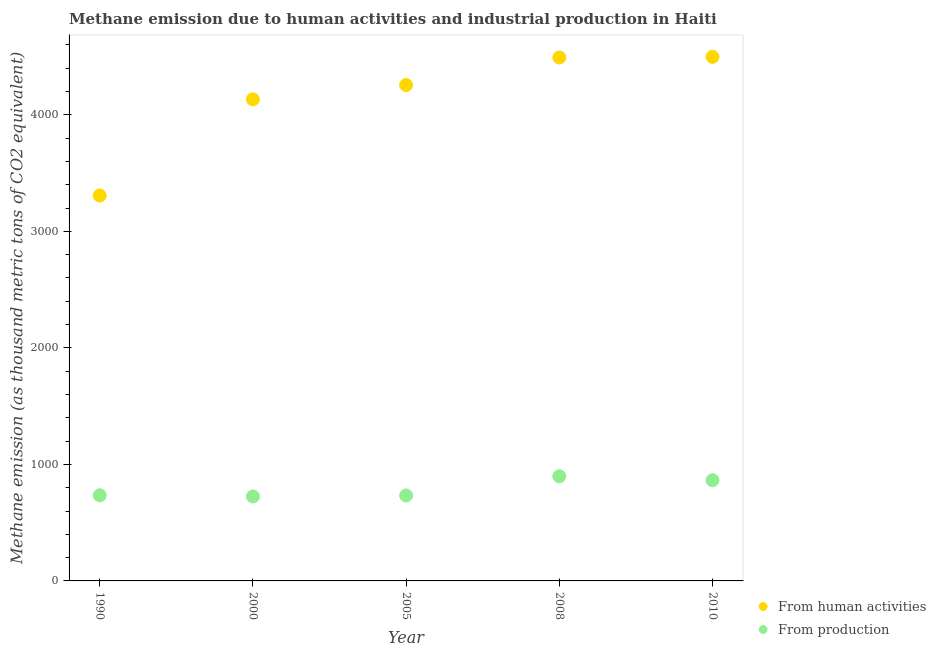How many different coloured dotlines are there?
Your response must be concise. 2. What is the amount of emissions from human activities in 2005?
Ensure brevity in your answer.  4255.4. Across all years, what is the maximum amount of emissions generated from industries?
Make the answer very short. 897.9. Across all years, what is the minimum amount of emissions from human activities?
Make the answer very short. 3307.8. In which year was the amount of emissions generated from industries minimum?
Ensure brevity in your answer.  2000. What is the total amount of emissions generated from industries in the graph?
Offer a terse response. 3955.3. What is the difference between the amount of emissions from human activities in 1990 and that in 2005?
Give a very brief answer. -947.6. What is the difference between the amount of emissions generated from industries in 2000 and the amount of emissions from human activities in 2008?
Make the answer very short. -3767.3. What is the average amount of emissions from human activities per year?
Give a very brief answer. 4137.04. In the year 2000, what is the difference between the amount of emissions generated from industries and amount of emissions from human activities?
Your answer should be very brief. -3407.8. In how many years, is the amount of emissions generated from industries greater than 3000 thousand metric tons?
Ensure brevity in your answer.  0. What is the ratio of the amount of emissions from human activities in 2000 to that in 2010?
Your response must be concise. 0.92. What is the difference between the highest and the second highest amount of emissions from human activities?
Your answer should be compact. 5.2. What is the difference between the highest and the lowest amount of emissions generated from industries?
Ensure brevity in your answer.  173.1. In how many years, is the amount of emissions from human activities greater than the average amount of emissions from human activities taken over all years?
Your response must be concise. 3. Is the sum of the amount of emissions from human activities in 2000 and 2005 greater than the maximum amount of emissions generated from industries across all years?
Offer a very short reply. Yes. Does the amount of emissions from human activities monotonically increase over the years?
Your answer should be compact. Yes. Is the amount of emissions generated from industries strictly greater than the amount of emissions from human activities over the years?
Keep it short and to the point. No. Is the amount of emissions from human activities strictly less than the amount of emissions generated from industries over the years?
Give a very brief answer. No. Are the values on the major ticks of Y-axis written in scientific E-notation?
Your response must be concise. No. Does the graph contain grids?
Offer a terse response. No. How many legend labels are there?
Make the answer very short. 2. What is the title of the graph?
Ensure brevity in your answer.  Methane emission due to human activities and industrial production in Haiti. What is the label or title of the Y-axis?
Keep it short and to the point. Methane emission (as thousand metric tons of CO2 equivalent). What is the Methane emission (as thousand metric tons of CO2 equivalent) in From human activities in 1990?
Your response must be concise. 3307.8. What is the Methane emission (as thousand metric tons of CO2 equivalent) of From production in 1990?
Your answer should be very brief. 734.9. What is the Methane emission (as thousand metric tons of CO2 equivalent) of From human activities in 2000?
Make the answer very short. 4132.6. What is the Methane emission (as thousand metric tons of CO2 equivalent) of From production in 2000?
Provide a short and direct response. 724.8. What is the Methane emission (as thousand metric tons of CO2 equivalent) of From human activities in 2005?
Offer a very short reply. 4255.4. What is the Methane emission (as thousand metric tons of CO2 equivalent) in From production in 2005?
Provide a short and direct response. 733.4. What is the Methane emission (as thousand metric tons of CO2 equivalent) of From human activities in 2008?
Keep it short and to the point. 4492.1. What is the Methane emission (as thousand metric tons of CO2 equivalent) of From production in 2008?
Offer a very short reply. 897.9. What is the Methane emission (as thousand metric tons of CO2 equivalent) in From human activities in 2010?
Keep it short and to the point. 4497.3. What is the Methane emission (as thousand metric tons of CO2 equivalent) in From production in 2010?
Keep it short and to the point. 864.3. Across all years, what is the maximum Methane emission (as thousand metric tons of CO2 equivalent) of From human activities?
Give a very brief answer. 4497.3. Across all years, what is the maximum Methane emission (as thousand metric tons of CO2 equivalent) of From production?
Your response must be concise. 897.9. Across all years, what is the minimum Methane emission (as thousand metric tons of CO2 equivalent) of From human activities?
Offer a very short reply. 3307.8. Across all years, what is the minimum Methane emission (as thousand metric tons of CO2 equivalent) of From production?
Provide a succinct answer. 724.8. What is the total Methane emission (as thousand metric tons of CO2 equivalent) in From human activities in the graph?
Provide a short and direct response. 2.07e+04. What is the total Methane emission (as thousand metric tons of CO2 equivalent) of From production in the graph?
Offer a terse response. 3955.3. What is the difference between the Methane emission (as thousand metric tons of CO2 equivalent) of From human activities in 1990 and that in 2000?
Provide a short and direct response. -824.8. What is the difference between the Methane emission (as thousand metric tons of CO2 equivalent) of From production in 1990 and that in 2000?
Your response must be concise. 10.1. What is the difference between the Methane emission (as thousand metric tons of CO2 equivalent) of From human activities in 1990 and that in 2005?
Your response must be concise. -947.6. What is the difference between the Methane emission (as thousand metric tons of CO2 equivalent) in From production in 1990 and that in 2005?
Provide a short and direct response. 1.5. What is the difference between the Methane emission (as thousand metric tons of CO2 equivalent) of From human activities in 1990 and that in 2008?
Give a very brief answer. -1184.3. What is the difference between the Methane emission (as thousand metric tons of CO2 equivalent) in From production in 1990 and that in 2008?
Keep it short and to the point. -163. What is the difference between the Methane emission (as thousand metric tons of CO2 equivalent) in From human activities in 1990 and that in 2010?
Give a very brief answer. -1189.5. What is the difference between the Methane emission (as thousand metric tons of CO2 equivalent) of From production in 1990 and that in 2010?
Provide a succinct answer. -129.4. What is the difference between the Methane emission (as thousand metric tons of CO2 equivalent) in From human activities in 2000 and that in 2005?
Provide a short and direct response. -122.8. What is the difference between the Methane emission (as thousand metric tons of CO2 equivalent) of From production in 2000 and that in 2005?
Your response must be concise. -8.6. What is the difference between the Methane emission (as thousand metric tons of CO2 equivalent) in From human activities in 2000 and that in 2008?
Offer a terse response. -359.5. What is the difference between the Methane emission (as thousand metric tons of CO2 equivalent) in From production in 2000 and that in 2008?
Offer a very short reply. -173.1. What is the difference between the Methane emission (as thousand metric tons of CO2 equivalent) of From human activities in 2000 and that in 2010?
Offer a terse response. -364.7. What is the difference between the Methane emission (as thousand metric tons of CO2 equivalent) of From production in 2000 and that in 2010?
Offer a very short reply. -139.5. What is the difference between the Methane emission (as thousand metric tons of CO2 equivalent) in From human activities in 2005 and that in 2008?
Offer a terse response. -236.7. What is the difference between the Methane emission (as thousand metric tons of CO2 equivalent) of From production in 2005 and that in 2008?
Offer a terse response. -164.5. What is the difference between the Methane emission (as thousand metric tons of CO2 equivalent) of From human activities in 2005 and that in 2010?
Ensure brevity in your answer.  -241.9. What is the difference between the Methane emission (as thousand metric tons of CO2 equivalent) in From production in 2005 and that in 2010?
Provide a succinct answer. -130.9. What is the difference between the Methane emission (as thousand metric tons of CO2 equivalent) in From production in 2008 and that in 2010?
Your response must be concise. 33.6. What is the difference between the Methane emission (as thousand metric tons of CO2 equivalent) of From human activities in 1990 and the Methane emission (as thousand metric tons of CO2 equivalent) of From production in 2000?
Offer a terse response. 2583. What is the difference between the Methane emission (as thousand metric tons of CO2 equivalent) in From human activities in 1990 and the Methane emission (as thousand metric tons of CO2 equivalent) in From production in 2005?
Give a very brief answer. 2574.4. What is the difference between the Methane emission (as thousand metric tons of CO2 equivalent) in From human activities in 1990 and the Methane emission (as thousand metric tons of CO2 equivalent) in From production in 2008?
Ensure brevity in your answer.  2409.9. What is the difference between the Methane emission (as thousand metric tons of CO2 equivalent) of From human activities in 1990 and the Methane emission (as thousand metric tons of CO2 equivalent) of From production in 2010?
Your response must be concise. 2443.5. What is the difference between the Methane emission (as thousand metric tons of CO2 equivalent) of From human activities in 2000 and the Methane emission (as thousand metric tons of CO2 equivalent) of From production in 2005?
Provide a short and direct response. 3399.2. What is the difference between the Methane emission (as thousand metric tons of CO2 equivalent) in From human activities in 2000 and the Methane emission (as thousand metric tons of CO2 equivalent) in From production in 2008?
Provide a short and direct response. 3234.7. What is the difference between the Methane emission (as thousand metric tons of CO2 equivalent) of From human activities in 2000 and the Methane emission (as thousand metric tons of CO2 equivalent) of From production in 2010?
Provide a succinct answer. 3268.3. What is the difference between the Methane emission (as thousand metric tons of CO2 equivalent) in From human activities in 2005 and the Methane emission (as thousand metric tons of CO2 equivalent) in From production in 2008?
Ensure brevity in your answer.  3357.5. What is the difference between the Methane emission (as thousand metric tons of CO2 equivalent) in From human activities in 2005 and the Methane emission (as thousand metric tons of CO2 equivalent) in From production in 2010?
Keep it short and to the point. 3391.1. What is the difference between the Methane emission (as thousand metric tons of CO2 equivalent) in From human activities in 2008 and the Methane emission (as thousand metric tons of CO2 equivalent) in From production in 2010?
Provide a short and direct response. 3627.8. What is the average Methane emission (as thousand metric tons of CO2 equivalent) of From human activities per year?
Give a very brief answer. 4137.04. What is the average Methane emission (as thousand metric tons of CO2 equivalent) of From production per year?
Ensure brevity in your answer.  791.06. In the year 1990, what is the difference between the Methane emission (as thousand metric tons of CO2 equivalent) of From human activities and Methane emission (as thousand metric tons of CO2 equivalent) of From production?
Your answer should be compact. 2572.9. In the year 2000, what is the difference between the Methane emission (as thousand metric tons of CO2 equivalent) of From human activities and Methane emission (as thousand metric tons of CO2 equivalent) of From production?
Your response must be concise. 3407.8. In the year 2005, what is the difference between the Methane emission (as thousand metric tons of CO2 equivalent) in From human activities and Methane emission (as thousand metric tons of CO2 equivalent) in From production?
Offer a terse response. 3522. In the year 2008, what is the difference between the Methane emission (as thousand metric tons of CO2 equivalent) of From human activities and Methane emission (as thousand metric tons of CO2 equivalent) of From production?
Keep it short and to the point. 3594.2. In the year 2010, what is the difference between the Methane emission (as thousand metric tons of CO2 equivalent) of From human activities and Methane emission (as thousand metric tons of CO2 equivalent) of From production?
Make the answer very short. 3633. What is the ratio of the Methane emission (as thousand metric tons of CO2 equivalent) of From human activities in 1990 to that in 2000?
Give a very brief answer. 0.8. What is the ratio of the Methane emission (as thousand metric tons of CO2 equivalent) of From production in 1990 to that in 2000?
Your answer should be very brief. 1.01. What is the ratio of the Methane emission (as thousand metric tons of CO2 equivalent) in From human activities in 1990 to that in 2005?
Keep it short and to the point. 0.78. What is the ratio of the Methane emission (as thousand metric tons of CO2 equivalent) of From production in 1990 to that in 2005?
Provide a short and direct response. 1. What is the ratio of the Methane emission (as thousand metric tons of CO2 equivalent) of From human activities in 1990 to that in 2008?
Your response must be concise. 0.74. What is the ratio of the Methane emission (as thousand metric tons of CO2 equivalent) in From production in 1990 to that in 2008?
Keep it short and to the point. 0.82. What is the ratio of the Methane emission (as thousand metric tons of CO2 equivalent) of From human activities in 1990 to that in 2010?
Offer a terse response. 0.74. What is the ratio of the Methane emission (as thousand metric tons of CO2 equivalent) in From production in 1990 to that in 2010?
Make the answer very short. 0.85. What is the ratio of the Methane emission (as thousand metric tons of CO2 equivalent) in From human activities in 2000 to that in 2005?
Your answer should be compact. 0.97. What is the ratio of the Methane emission (as thousand metric tons of CO2 equivalent) in From production in 2000 to that in 2005?
Your answer should be very brief. 0.99. What is the ratio of the Methane emission (as thousand metric tons of CO2 equivalent) in From human activities in 2000 to that in 2008?
Your response must be concise. 0.92. What is the ratio of the Methane emission (as thousand metric tons of CO2 equivalent) of From production in 2000 to that in 2008?
Provide a succinct answer. 0.81. What is the ratio of the Methane emission (as thousand metric tons of CO2 equivalent) of From human activities in 2000 to that in 2010?
Your answer should be very brief. 0.92. What is the ratio of the Methane emission (as thousand metric tons of CO2 equivalent) in From production in 2000 to that in 2010?
Ensure brevity in your answer.  0.84. What is the ratio of the Methane emission (as thousand metric tons of CO2 equivalent) in From human activities in 2005 to that in 2008?
Offer a very short reply. 0.95. What is the ratio of the Methane emission (as thousand metric tons of CO2 equivalent) of From production in 2005 to that in 2008?
Provide a short and direct response. 0.82. What is the ratio of the Methane emission (as thousand metric tons of CO2 equivalent) of From human activities in 2005 to that in 2010?
Give a very brief answer. 0.95. What is the ratio of the Methane emission (as thousand metric tons of CO2 equivalent) of From production in 2005 to that in 2010?
Your answer should be very brief. 0.85. What is the ratio of the Methane emission (as thousand metric tons of CO2 equivalent) of From production in 2008 to that in 2010?
Keep it short and to the point. 1.04. What is the difference between the highest and the second highest Methane emission (as thousand metric tons of CO2 equivalent) in From human activities?
Provide a succinct answer. 5.2. What is the difference between the highest and the second highest Methane emission (as thousand metric tons of CO2 equivalent) in From production?
Your answer should be compact. 33.6. What is the difference between the highest and the lowest Methane emission (as thousand metric tons of CO2 equivalent) of From human activities?
Ensure brevity in your answer.  1189.5. What is the difference between the highest and the lowest Methane emission (as thousand metric tons of CO2 equivalent) in From production?
Your answer should be compact. 173.1. 